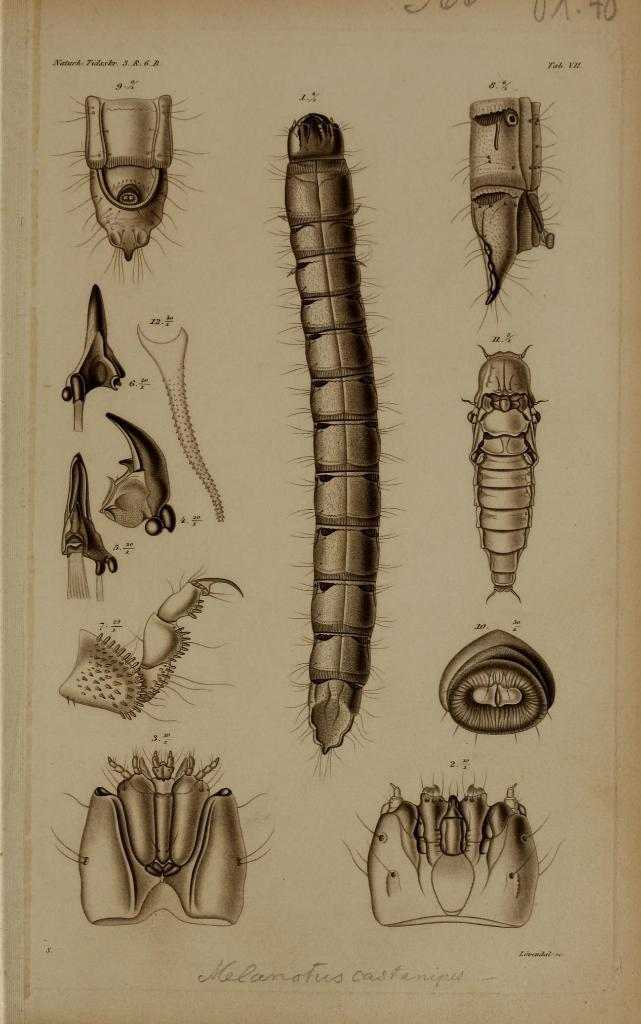What type of animals are depicted on the paper in the image? There are pictures of reptiles on the paper. What else can be found on the paper besides the images of reptiles? There is text on the paper. What type of wheel is visible on the paper? There is no wheel present on the paper; it features pictures of reptiles and text. What color are the trousers worn by the reptiles in the image? There are no reptiles wearing trousers in the image, as they are depicted in pictures on the paper. 